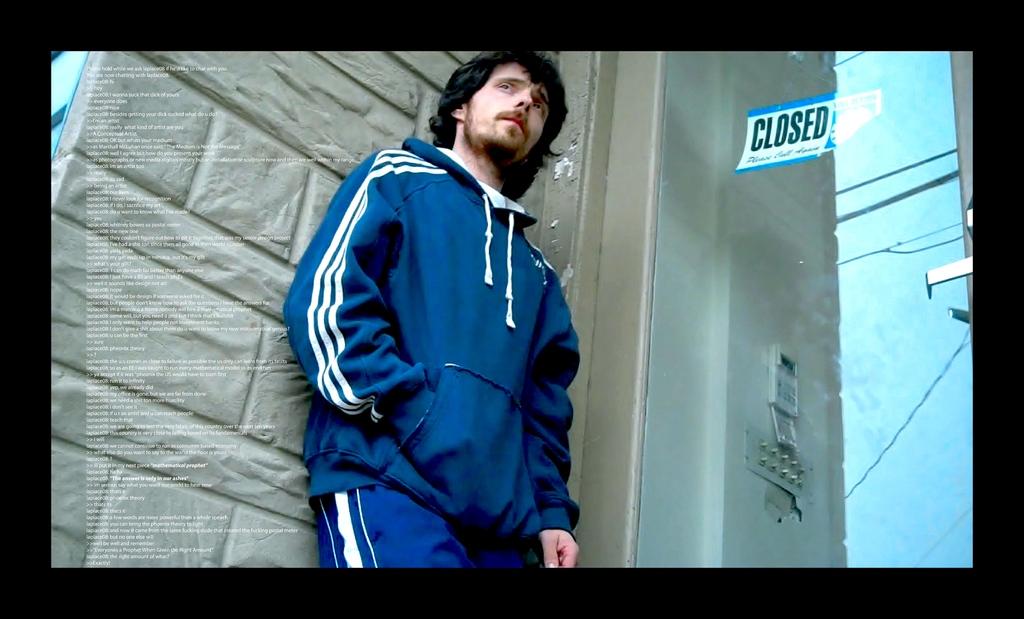Is the store open?
Ensure brevity in your answer.  No. 